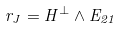Convert formula to latex. <formula><loc_0><loc_0><loc_500><loc_500>r _ { J } = H ^ { \perp } \wedge E _ { 2 1 }</formula> 